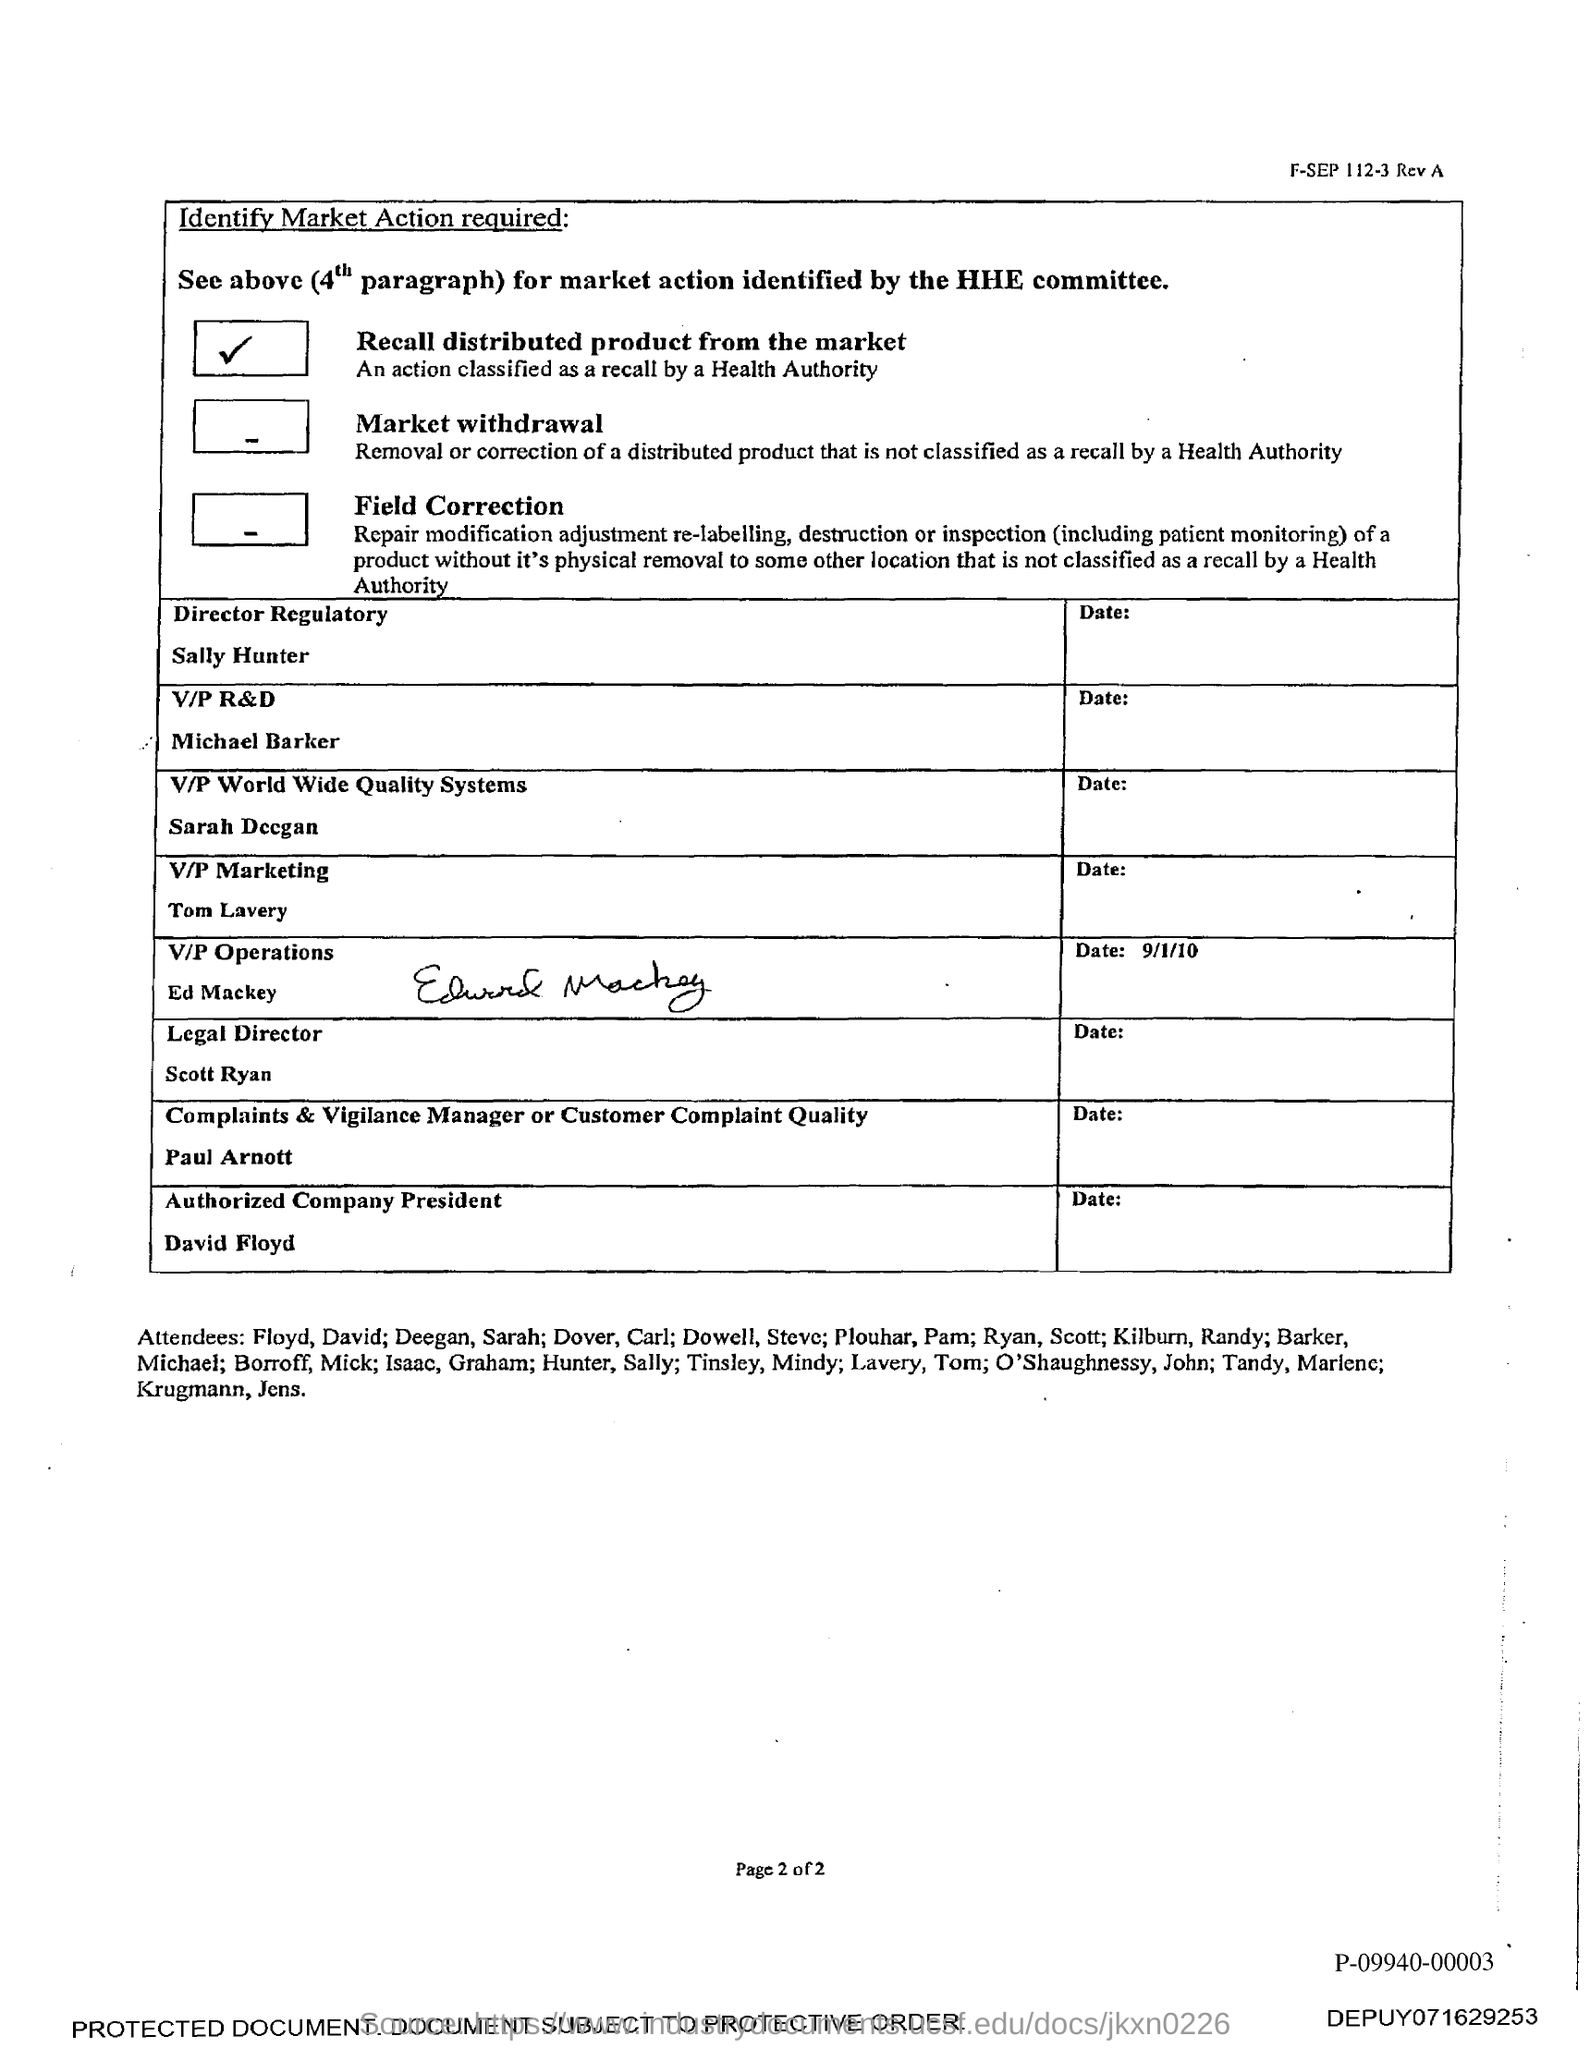Indicate a few pertinent items in this graphic. Sally Hunter holds the designation of Director of Regulatory Affairs. The document indicates that David Floyd is the authorized company president. Scott Ryan's designation is Legal Director. 